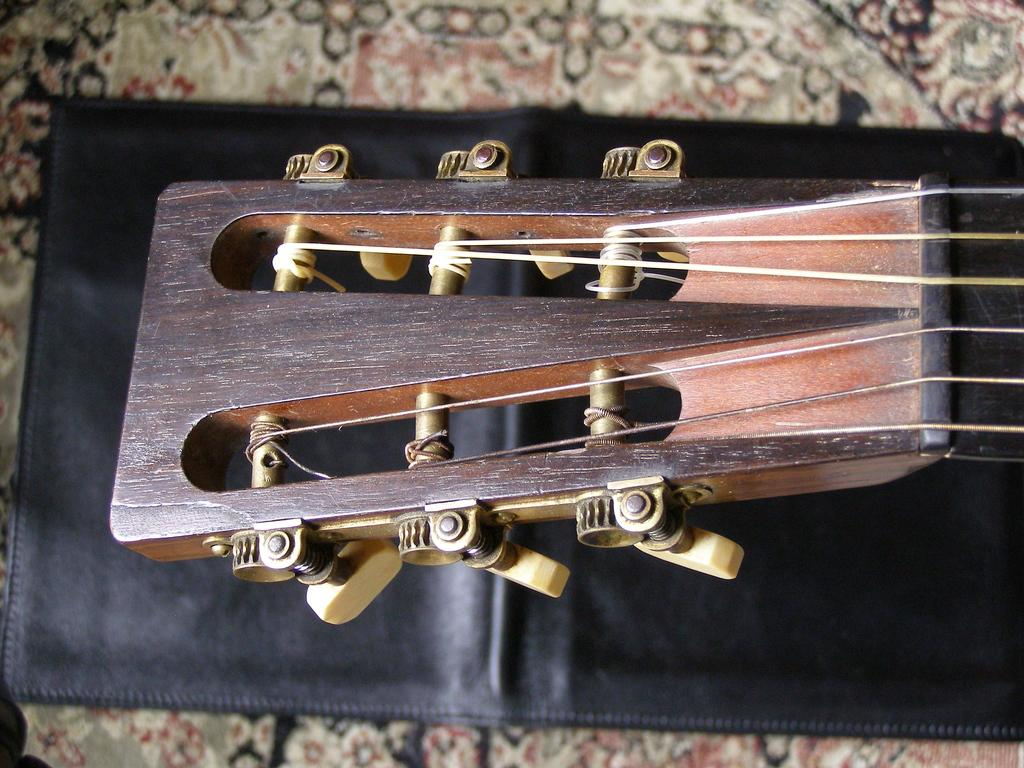What musical instrument is present in the image? There is a guitar in the image. Which part of the guitar is visible in the image? The topmost part of the guitar is visible. Where is the guitar placed in the image? The guitar is placed on a table. What type of powder is being used to fuel the guitar in the image? There is no powder or fuel present in the image; it features a guitar placed on a table. 